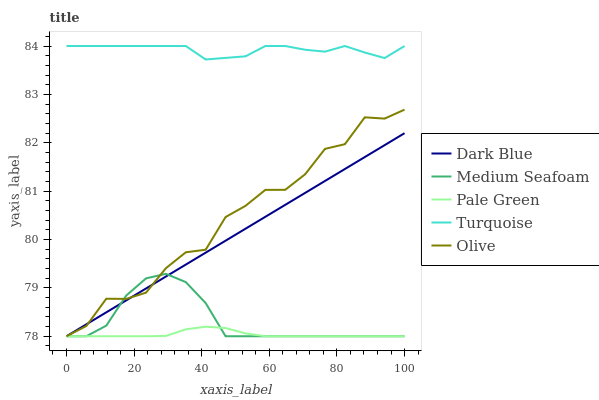Does Pale Green have the minimum area under the curve?
Answer yes or no. Yes. Does Turquoise have the maximum area under the curve?
Answer yes or no. Yes. Does Dark Blue have the minimum area under the curve?
Answer yes or no. No. Does Dark Blue have the maximum area under the curve?
Answer yes or no. No. Is Dark Blue the smoothest?
Answer yes or no. Yes. Is Olive the roughest?
Answer yes or no. Yes. Is Turquoise the smoothest?
Answer yes or no. No. Is Turquoise the roughest?
Answer yes or no. No. Does Olive have the lowest value?
Answer yes or no. Yes. Does Turquoise have the lowest value?
Answer yes or no. No. Does Turquoise have the highest value?
Answer yes or no. Yes. Does Dark Blue have the highest value?
Answer yes or no. No. Is Medium Seafoam less than Turquoise?
Answer yes or no. Yes. Is Turquoise greater than Dark Blue?
Answer yes or no. Yes. Does Dark Blue intersect Medium Seafoam?
Answer yes or no. Yes. Is Dark Blue less than Medium Seafoam?
Answer yes or no. No. Is Dark Blue greater than Medium Seafoam?
Answer yes or no. No. Does Medium Seafoam intersect Turquoise?
Answer yes or no. No. 